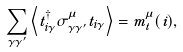Convert formula to latex. <formula><loc_0><loc_0><loc_500><loc_500>\sum _ { \gamma \gamma ^ { \prime } } \left \langle t _ { i \gamma } ^ { \dagger } \sigma _ { \gamma \gamma ^ { \prime } } ^ { \mu } t _ { i \gamma } \right \rangle = m _ { t } ^ { \mu } ( i ) ,</formula> 